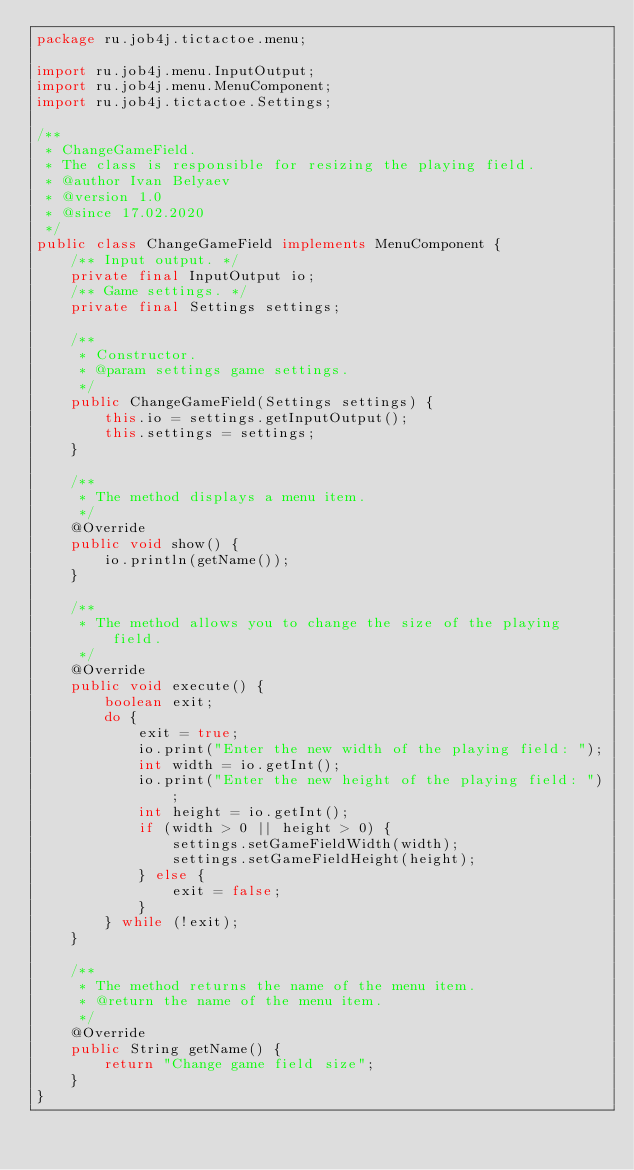<code> <loc_0><loc_0><loc_500><loc_500><_Java_>package ru.job4j.tictactoe.menu;

import ru.job4j.menu.InputOutput;
import ru.job4j.menu.MenuComponent;
import ru.job4j.tictactoe.Settings;

/**
 * ChangeGameField.
 * The class is responsible for resizing the playing field.
 * @author Ivan Belyaev
 * @version 1.0
 * @since 17.02.2020
 */
public class ChangeGameField implements MenuComponent {
    /** Input output. */
    private final InputOutput io;
    /** Game settings. */
    private final Settings settings;

    /**
     * Constructor.
     * @param settings game settings.
     */
    public ChangeGameField(Settings settings) {
        this.io = settings.getInputOutput();
        this.settings = settings;
    }

    /**
     * The method displays a menu item.
     */
    @Override
    public void show() {
        io.println(getName());
    }

    /**
     * The method allows you to change the size of the playing field.
     */
    @Override
    public void execute() {
        boolean exit;
        do {
            exit = true;
            io.print("Enter the new width of the playing field: ");
            int width = io.getInt();
            io.print("Enter the new height of the playing field: ");
            int height = io.getInt();
            if (width > 0 || height > 0) {
                settings.setGameFieldWidth(width);
                settings.setGameFieldHeight(height);
            } else {
                exit = false;
            }
        } while (!exit);
    }

    /**
     * The method returns the name of the menu item.
     * @return the name of the menu item.
     */
    @Override
    public String getName() {
        return "Change game field size";
    }
}
</code> 